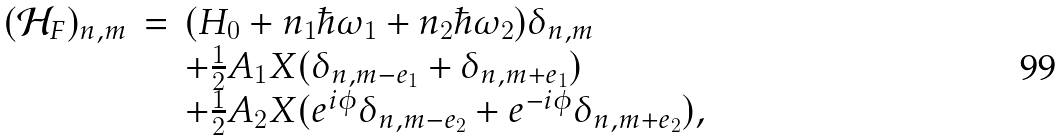<formula> <loc_0><loc_0><loc_500><loc_500>\begin{array} { l c l } ( \mathcal { H } _ { F } ) _ { n , m } & = & ( H _ { 0 } + n _ { 1 } \hbar { \omega } _ { 1 } + n _ { 2 } \hbar { \omega } _ { 2 } ) \delta _ { n , m } \\ & & + \frac { 1 } { 2 } A _ { 1 } X ( \delta _ { n , m - e _ { 1 } } + \delta _ { n , m + e _ { 1 } } ) \\ & & + \frac { 1 } { 2 } A _ { 2 } X ( e ^ { i \phi } \delta _ { n , m - e _ { 2 } } + e ^ { - i \phi } \delta _ { n , m + e _ { 2 } } ) , \end{array}</formula> 